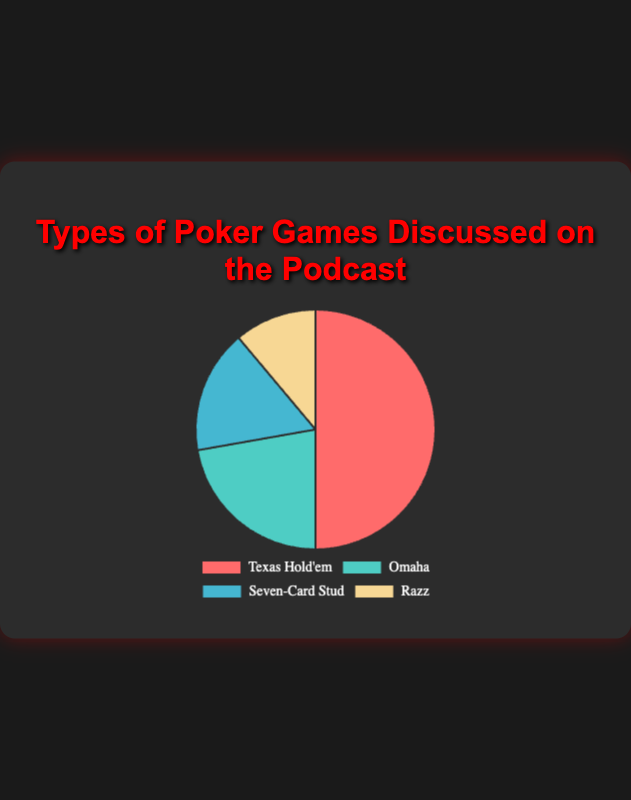What percentage of episodes covered Texas Hold'em? To find the percentage, divide the number of episodes covering Texas Hold'em (45) by the total number of episodes (45+20+15+10), then multiply by 100. (45 / 90) * 100 = 50%.
Answer: 50% Which poker game is the second most discussed on the podcast? Compare the episodes covered by each game. Texas Hold'em has 45 episodes, Omaha has 20 episodes, Seven-Card Stud has 15 episodes, and Razz has 10 episodes. Omaha is second most discussed with 20 episodes.
Answer: Omaha How many more episodes covered Texas Hold'em compared to Razz? Subtract the number of episodes for Razz (10) from that of Texas Hold'em (45). 45 - 10 = 35.
Answer: 35 What is the average number of episodes covered per game? Sum the number of episodes for all games (45+20+15+10=90) and divide by the total number of games (4). 90 / 4 = 22.5.
Answer: 22.5 Which game had the least coverage, and how many episodes was it discussed in? Razz is the poker game with the lowest coverage, which has 10 episodes.
Answer: Razz, 10 episodes By how many episodes does the coverage of Omaha exceed that of Seven-Card Stud? Subtract the number of episodes for Seven-Card Stud (15) from that of Omaha (20). 20 - 15 = 5.
Answer: 5 What is the combined coverage of Seven-Card Stud and Razz? Add the number of episodes for Seven-Card Stud (15) and Razz (10). 15 + 10 = 25.
Answer: 25 What color represents Omaha in the pie chart? The pie chart uses four different colors. Omaha is represented by the second color in the list: green.
Answer: green Is the number of episodes covering Texas Hold'em more than double that of Seven-Card Stud? Check if 45 (Texas Hold'em) is more than double 15 (Seven-Card Stud). Double of 15 is 30, and 45 is indeed more than 30.
Answer: Yes What is the difference between the highest and the lowest number of episodes covered for any game? Subtract the episodes of the game with the lowest coverage (Razz with 10 episodes) from the game with the highest coverage (Texas Hold'em with 45 episodes). 45 - 10 = 35.
Answer: 35 